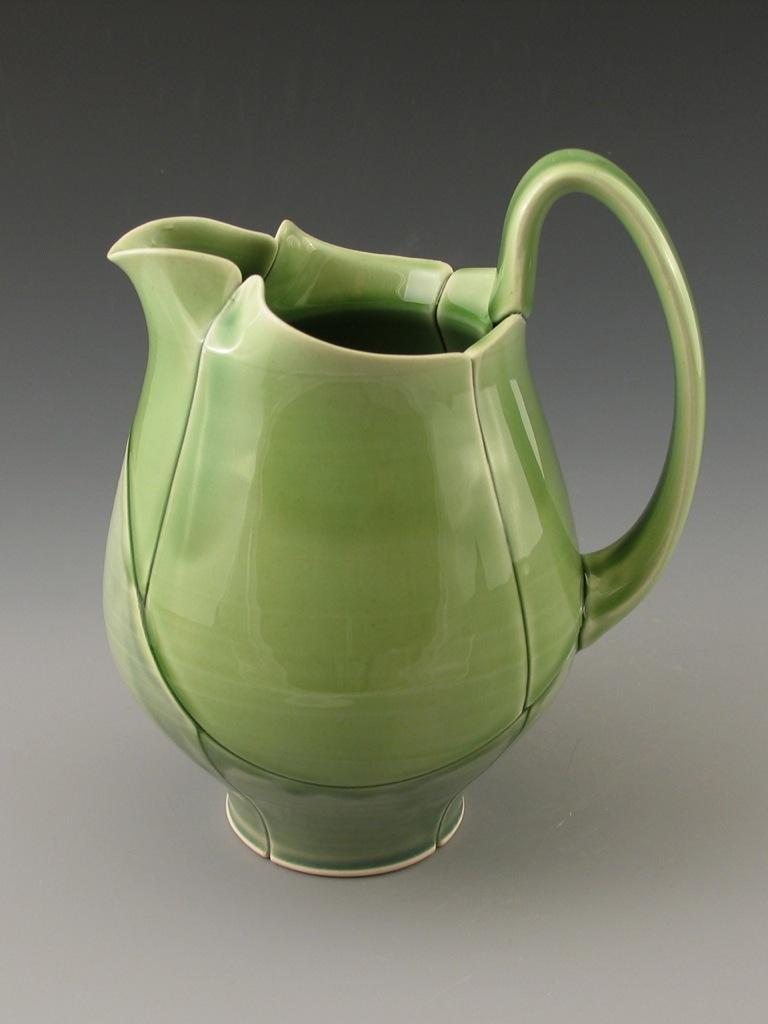What type of object is in the image? There is a pottery pitcher in the image. What is the pottery pitcher resting on? The pottery pitcher is on an object. What is the price of the sand in the image? There is no sand present in the image, so it is not possible to determine the price of any sand. 